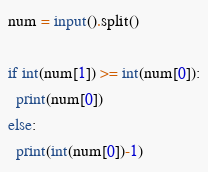<code> <loc_0><loc_0><loc_500><loc_500><_Python_>num = input().split()

if int(num[1]) >= int(num[0]):
  print(num[0])
else:
  print(int(num[0])-1)</code> 